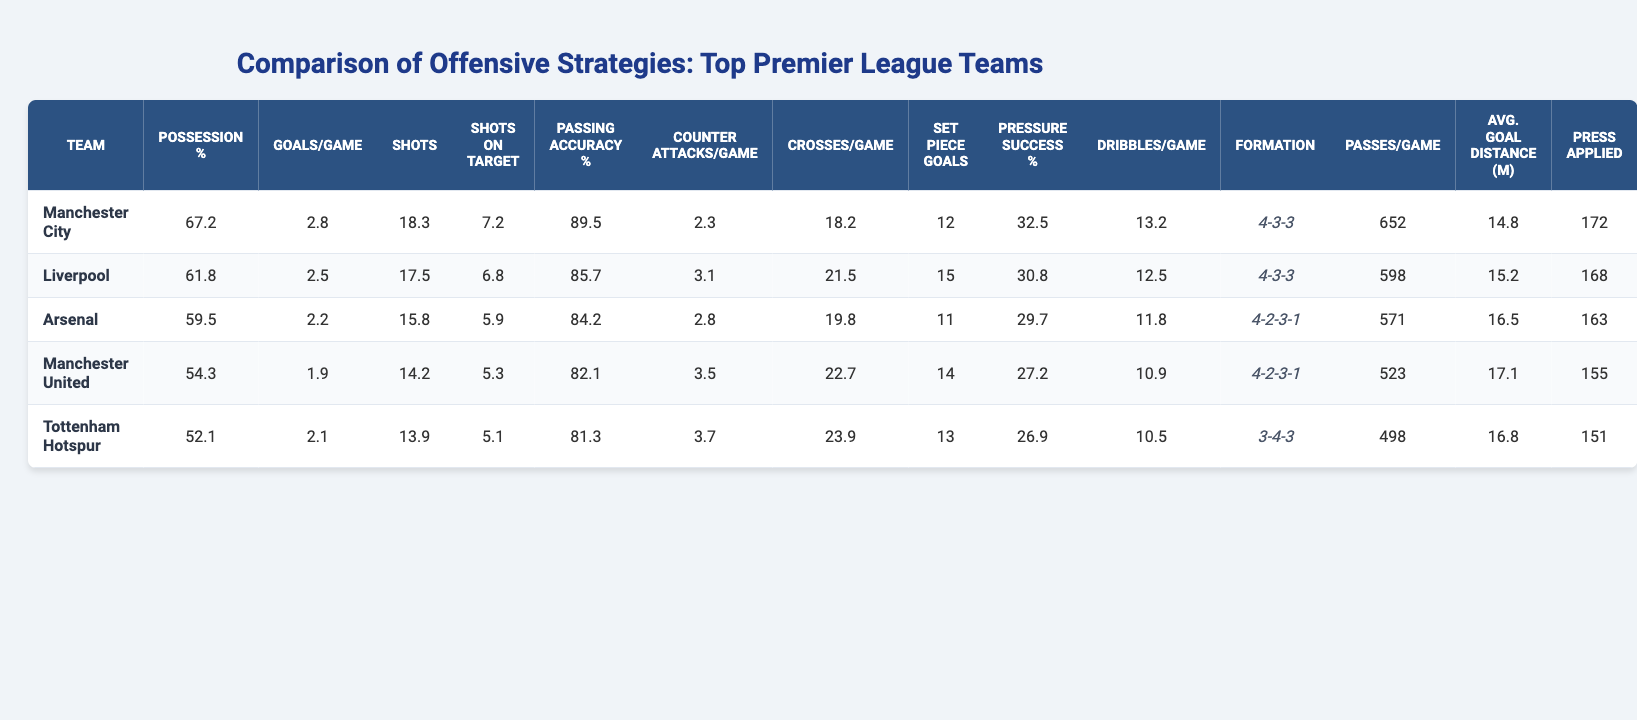What is the possession percentage of Manchester City? The table provides a specific column for possession percentage for each team. For Manchester City, the possession percentage is listed directly as 67.2%.
Answer: 67.2% Which team has the highest average goals per game? By comparing the 'Goals/Game' column in the table, Manchester City has the highest average with 2.8 goals per game, more than any other team listed.
Answer: Manchester City What is the passing accuracy of Liverpool? The passing accuracy for Liverpool is found in the 'Passing Accuracy %' column. It states that Liverpool has a passing accuracy of 85.7%.
Answer: 85.7% How many more average shots per game does Arsenal have compared to Tottenham Hotspur? Arsenal averages 15.8 shots per game, while Tottenham Hotspur averages 13.9. The difference is 15.8 - 13.9 = 1.9 shots more for Arsenal.
Answer: 1.9 Is the average number of counter attacks per game greater for Manchester United than Arsenal? Manchester United has an average of 3.5 counter attacks per game, while Arsenal has 2.8. Since 3.5 is greater than 2.8, the statement is true.
Answer: Yes Which team has the least average dribbles per game and what is that value? The 'Dribbles/Game' column should be compared. Tottenham Hotspur has the least average with 10.5 dribbles per game compared to the others.
Answer: Tottenham Hotspur, 10.5 What is the total number of set piece goals among all teams? By summing the 'Set Piece Goals' for each team: 12 + 15 + 11 + 14 + 13 = 65. Therefore, the total number of set piece goals is 65.
Answer: 65 What is the average possession percentage of the bottom two teams in the list? The bottom two teams are Tottenham Hotspur and Manchester United with possession percentages of 52.1% and 54.3% respectively. The average is (52.1 + 54.3) / 2 = 53.2%.
Answer: 53.2% Which team has the highest pressure success rate and what is that rate? Checking the 'Pressure Success %' column shows Manchester City has the highest rate at 32.5%.
Answer: Manchester City, 32.5% If we consider the average goals per game across all teams, what is that average? First, sum the goals: (2.8 + 2.5 + 2.2 + 1.9 + 2.1) = 11.5. Then, divide by 5: 11.5 / 5 = 2.3, giving the average goals per game.
Answer: 2.3 